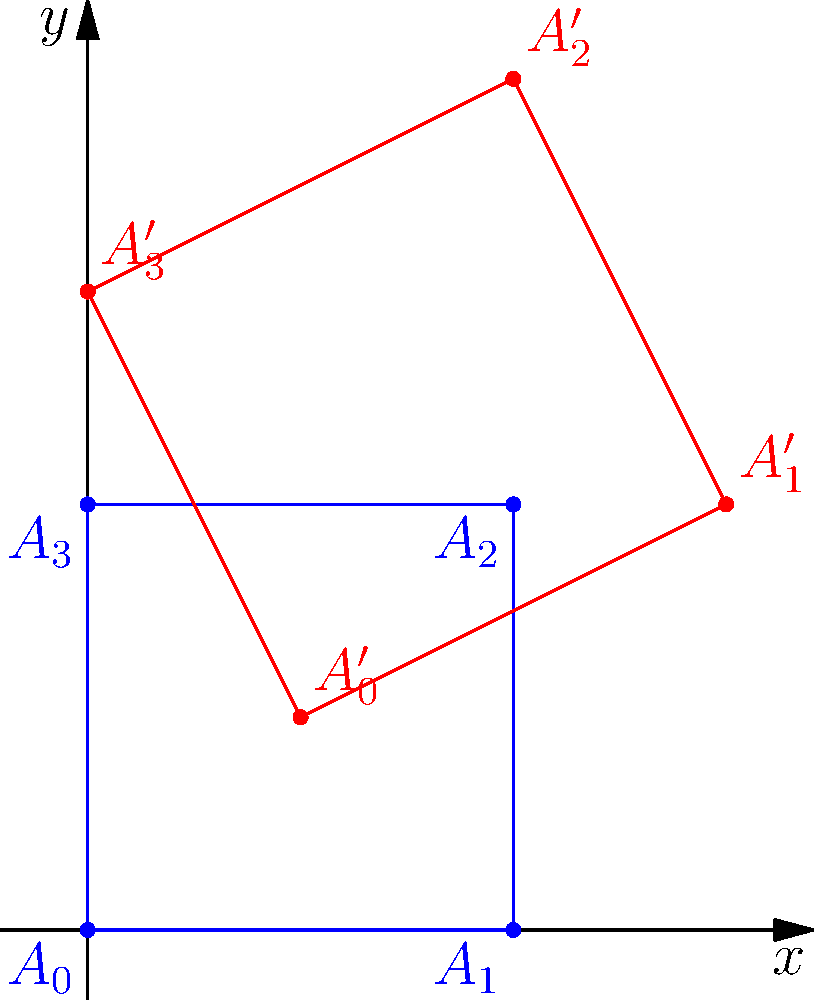In a digital storytelling platform, you want to implement a scene transition effect using coordinate transformations. The initial scene is represented by a square $A_0A_1A_2A_3$ with vertices at $(0,0)$, $(2,0)$, $(2,2)$, and $(0,2)$. After the transformation, the square becomes the quadrilateral $A'_0A'_1A'_2A'_3$ with vertices at $(1,1)$, $(3,2)$, $(2,4)$, and $(0,3)$. What is the transformation matrix $T$ that maps the original square to the transformed quadrilateral? To find the transformation matrix $T$, we need to solve the equation $T \cdot A = A'$, where $A$ represents the original coordinates and $A'$ the transformed coordinates.

Step 1: Set up the equation
$$
\begin{bmatrix}
a & b \\
c & d
\end{bmatrix}
\begin{bmatrix}
0 & 2 & 2 & 0 \\
0 & 0 & 2 & 2
\end{bmatrix} =
\begin{bmatrix}
1 & 3 & 2 & 0 \\
1 & 2 & 4 & 3
\end{bmatrix}
$$

Step 2: Solve for $a$, $b$, $c$, and $d$
From the first column:
$a \cdot 0 + b \cdot 0 = 1$, $c \cdot 0 + d \cdot 0 = 1$
This gives us the translation: $b = 1$, $d = 1$

From the second column:
$a \cdot 2 + b \cdot 0 = 3$, $c \cdot 2 + d \cdot 0 = 2$
Substituting known values: $2a + 1 = 3$, $2c + 1 = 2$
Solving: $a = 1$, $c = 0.5$

Step 3: Verify with the remaining columns
For $(2,2)$: $(1 \cdot 2 + 1 \cdot 2, 0.5 \cdot 2 + 1 \cdot 2) = (4,3)$
For $(0,2)$: $(1 \cdot 0 + 1 \cdot 2, 0.5 \cdot 0 + 1 \cdot 2) = (2,2)$

These match the transformed coordinates, confirming our solution.

Step 4: Write the final transformation matrix
$$T = \begin{bmatrix}
1 & 1 \\
0.5 & 1
\end{bmatrix}$$
Answer: $$T = \begin{bmatrix}
1 & 1 \\
0.5 & 1
\end{bmatrix}$$ 